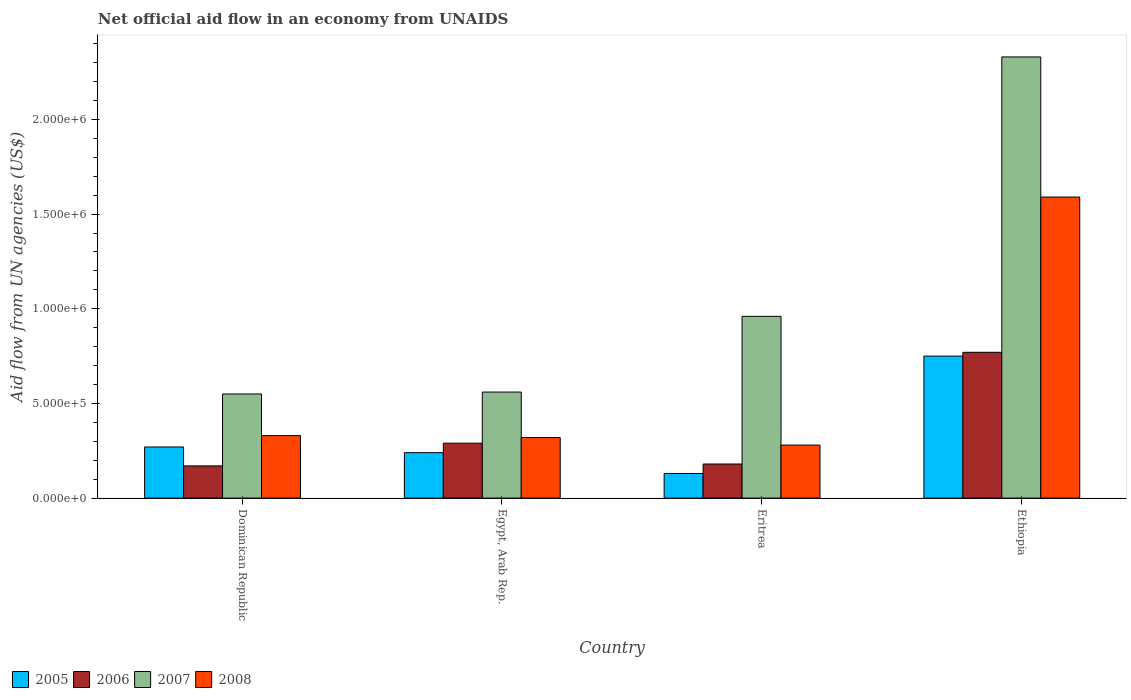How many groups of bars are there?
Offer a terse response. 4. Are the number of bars on each tick of the X-axis equal?
Provide a succinct answer. Yes. How many bars are there on the 3rd tick from the left?
Make the answer very short. 4. How many bars are there on the 2nd tick from the right?
Your answer should be compact. 4. What is the label of the 4th group of bars from the left?
Ensure brevity in your answer.  Ethiopia. Across all countries, what is the maximum net official aid flow in 2007?
Make the answer very short. 2.33e+06. In which country was the net official aid flow in 2007 maximum?
Your answer should be very brief. Ethiopia. In which country was the net official aid flow in 2007 minimum?
Make the answer very short. Dominican Republic. What is the total net official aid flow in 2006 in the graph?
Give a very brief answer. 1.41e+06. What is the difference between the net official aid flow in 2005 in Egypt, Arab Rep. and that in Eritrea?
Keep it short and to the point. 1.10e+05. What is the difference between the net official aid flow in 2007 in Eritrea and the net official aid flow in 2008 in Egypt, Arab Rep.?
Provide a succinct answer. 6.40e+05. What is the average net official aid flow in 2006 per country?
Provide a short and direct response. 3.52e+05. In how many countries, is the net official aid flow in 2008 greater than 1400000 US$?
Your response must be concise. 1. What is the ratio of the net official aid flow in 2005 in Dominican Republic to that in Ethiopia?
Offer a very short reply. 0.36. What is the difference between the highest and the second highest net official aid flow in 2006?
Offer a very short reply. 5.90e+05. What is the difference between the highest and the lowest net official aid flow in 2006?
Provide a short and direct response. 6.00e+05. Is the sum of the net official aid flow in 2005 in Egypt, Arab Rep. and Eritrea greater than the maximum net official aid flow in 2006 across all countries?
Your response must be concise. No. Is it the case that in every country, the sum of the net official aid flow in 2008 and net official aid flow in 2007 is greater than the sum of net official aid flow in 2005 and net official aid flow in 2006?
Keep it short and to the point. Yes. Is it the case that in every country, the sum of the net official aid flow in 2006 and net official aid flow in 2005 is greater than the net official aid flow in 2008?
Your response must be concise. No. Are all the bars in the graph horizontal?
Provide a succinct answer. No. How many countries are there in the graph?
Make the answer very short. 4. What is the difference between two consecutive major ticks on the Y-axis?
Your response must be concise. 5.00e+05. Are the values on the major ticks of Y-axis written in scientific E-notation?
Offer a terse response. Yes. Does the graph contain any zero values?
Provide a succinct answer. No. Does the graph contain grids?
Keep it short and to the point. No. Where does the legend appear in the graph?
Give a very brief answer. Bottom left. How many legend labels are there?
Ensure brevity in your answer.  4. What is the title of the graph?
Give a very brief answer. Net official aid flow in an economy from UNAIDS. Does "2011" appear as one of the legend labels in the graph?
Offer a very short reply. No. What is the label or title of the Y-axis?
Ensure brevity in your answer.  Aid flow from UN agencies (US$). What is the Aid flow from UN agencies (US$) in 2006 in Dominican Republic?
Keep it short and to the point. 1.70e+05. What is the Aid flow from UN agencies (US$) of 2007 in Dominican Republic?
Keep it short and to the point. 5.50e+05. What is the Aid flow from UN agencies (US$) in 2008 in Dominican Republic?
Give a very brief answer. 3.30e+05. What is the Aid flow from UN agencies (US$) of 2007 in Egypt, Arab Rep.?
Offer a very short reply. 5.60e+05. What is the Aid flow from UN agencies (US$) of 2007 in Eritrea?
Your answer should be compact. 9.60e+05. What is the Aid flow from UN agencies (US$) in 2008 in Eritrea?
Your response must be concise. 2.80e+05. What is the Aid flow from UN agencies (US$) of 2005 in Ethiopia?
Your response must be concise. 7.50e+05. What is the Aid flow from UN agencies (US$) in 2006 in Ethiopia?
Offer a terse response. 7.70e+05. What is the Aid flow from UN agencies (US$) in 2007 in Ethiopia?
Your answer should be compact. 2.33e+06. What is the Aid flow from UN agencies (US$) in 2008 in Ethiopia?
Keep it short and to the point. 1.59e+06. Across all countries, what is the maximum Aid flow from UN agencies (US$) in 2005?
Provide a short and direct response. 7.50e+05. Across all countries, what is the maximum Aid flow from UN agencies (US$) of 2006?
Your answer should be very brief. 7.70e+05. Across all countries, what is the maximum Aid flow from UN agencies (US$) in 2007?
Offer a very short reply. 2.33e+06. Across all countries, what is the maximum Aid flow from UN agencies (US$) of 2008?
Provide a short and direct response. 1.59e+06. Across all countries, what is the minimum Aid flow from UN agencies (US$) of 2006?
Make the answer very short. 1.70e+05. Across all countries, what is the minimum Aid flow from UN agencies (US$) in 2008?
Give a very brief answer. 2.80e+05. What is the total Aid flow from UN agencies (US$) in 2005 in the graph?
Your response must be concise. 1.39e+06. What is the total Aid flow from UN agencies (US$) of 2006 in the graph?
Offer a very short reply. 1.41e+06. What is the total Aid flow from UN agencies (US$) of 2007 in the graph?
Your answer should be compact. 4.40e+06. What is the total Aid flow from UN agencies (US$) of 2008 in the graph?
Provide a short and direct response. 2.52e+06. What is the difference between the Aid flow from UN agencies (US$) of 2008 in Dominican Republic and that in Egypt, Arab Rep.?
Make the answer very short. 10000. What is the difference between the Aid flow from UN agencies (US$) in 2005 in Dominican Republic and that in Eritrea?
Offer a terse response. 1.40e+05. What is the difference between the Aid flow from UN agencies (US$) of 2006 in Dominican Republic and that in Eritrea?
Your answer should be compact. -10000. What is the difference between the Aid flow from UN agencies (US$) of 2007 in Dominican Republic and that in Eritrea?
Offer a very short reply. -4.10e+05. What is the difference between the Aid flow from UN agencies (US$) in 2005 in Dominican Republic and that in Ethiopia?
Your answer should be very brief. -4.80e+05. What is the difference between the Aid flow from UN agencies (US$) of 2006 in Dominican Republic and that in Ethiopia?
Your answer should be very brief. -6.00e+05. What is the difference between the Aid flow from UN agencies (US$) of 2007 in Dominican Republic and that in Ethiopia?
Your answer should be compact. -1.78e+06. What is the difference between the Aid flow from UN agencies (US$) in 2008 in Dominican Republic and that in Ethiopia?
Your response must be concise. -1.26e+06. What is the difference between the Aid flow from UN agencies (US$) of 2005 in Egypt, Arab Rep. and that in Eritrea?
Your answer should be compact. 1.10e+05. What is the difference between the Aid flow from UN agencies (US$) of 2007 in Egypt, Arab Rep. and that in Eritrea?
Give a very brief answer. -4.00e+05. What is the difference between the Aid flow from UN agencies (US$) of 2005 in Egypt, Arab Rep. and that in Ethiopia?
Give a very brief answer. -5.10e+05. What is the difference between the Aid flow from UN agencies (US$) of 2006 in Egypt, Arab Rep. and that in Ethiopia?
Give a very brief answer. -4.80e+05. What is the difference between the Aid flow from UN agencies (US$) of 2007 in Egypt, Arab Rep. and that in Ethiopia?
Offer a terse response. -1.77e+06. What is the difference between the Aid flow from UN agencies (US$) in 2008 in Egypt, Arab Rep. and that in Ethiopia?
Provide a succinct answer. -1.27e+06. What is the difference between the Aid flow from UN agencies (US$) in 2005 in Eritrea and that in Ethiopia?
Keep it short and to the point. -6.20e+05. What is the difference between the Aid flow from UN agencies (US$) of 2006 in Eritrea and that in Ethiopia?
Make the answer very short. -5.90e+05. What is the difference between the Aid flow from UN agencies (US$) of 2007 in Eritrea and that in Ethiopia?
Your response must be concise. -1.37e+06. What is the difference between the Aid flow from UN agencies (US$) of 2008 in Eritrea and that in Ethiopia?
Ensure brevity in your answer.  -1.31e+06. What is the difference between the Aid flow from UN agencies (US$) in 2005 in Dominican Republic and the Aid flow from UN agencies (US$) in 2007 in Egypt, Arab Rep.?
Make the answer very short. -2.90e+05. What is the difference between the Aid flow from UN agencies (US$) in 2006 in Dominican Republic and the Aid flow from UN agencies (US$) in 2007 in Egypt, Arab Rep.?
Your answer should be compact. -3.90e+05. What is the difference between the Aid flow from UN agencies (US$) of 2006 in Dominican Republic and the Aid flow from UN agencies (US$) of 2008 in Egypt, Arab Rep.?
Give a very brief answer. -1.50e+05. What is the difference between the Aid flow from UN agencies (US$) of 2005 in Dominican Republic and the Aid flow from UN agencies (US$) of 2007 in Eritrea?
Make the answer very short. -6.90e+05. What is the difference between the Aid flow from UN agencies (US$) in 2006 in Dominican Republic and the Aid flow from UN agencies (US$) in 2007 in Eritrea?
Offer a terse response. -7.90e+05. What is the difference between the Aid flow from UN agencies (US$) in 2007 in Dominican Republic and the Aid flow from UN agencies (US$) in 2008 in Eritrea?
Make the answer very short. 2.70e+05. What is the difference between the Aid flow from UN agencies (US$) of 2005 in Dominican Republic and the Aid flow from UN agencies (US$) of 2006 in Ethiopia?
Provide a short and direct response. -5.00e+05. What is the difference between the Aid flow from UN agencies (US$) of 2005 in Dominican Republic and the Aid flow from UN agencies (US$) of 2007 in Ethiopia?
Your response must be concise. -2.06e+06. What is the difference between the Aid flow from UN agencies (US$) of 2005 in Dominican Republic and the Aid flow from UN agencies (US$) of 2008 in Ethiopia?
Provide a short and direct response. -1.32e+06. What is the difference between the Aid flow from UN agencies (US$) in 2006 in Dominican Republic and the Aid flow from UN agencies (US$) in 2007 in Ethiopia?
Provide a short and direct response. -2.16e+06. What is the difference between the Aid flow from UN agencies (US$) of 2006 in Dominican Republic and the Aid flow from UN agencies (US$) of 2008 in Ethiopia?
Your answer should be very brief. -1.42e+06. What is the difference between the Aid flow from UN agencies (US$) of 2007 in Dominican Republic and the Aid flow from UN agencies (US$) of 2008 in Ethiopia?
Your answer should be very brief. -1.04e+06. What is the difference between the Aid flow from UN agencies (US$) in 2005 in Egypt, Arab Rep. and the Aid flow from UN agencies (US$) in 2007 in Eritrea?
Your response must be concise. -7.20e+05. What is the difference between the Aid flow from UN agencies (US$) in 2005 in Egypt, Arab Rep. and the Aid flow from UN agencies (US$) in 2008 in Eritrea?
Offer a terse response. -4.00e+04. What is the difference between the Aid flow from UN agencies (US$) in 2006 in Egypt, Arab Rep. and the Aid flow from UN agencies (US$) in 2007 in Eritrea?
Your answer should be compact. -6.70e+05. What is the difference between the Aid flow from UN agencies (US$) in 2006 in Egypt, Arab Rep. and the Aid flow from UN agencies (US$) in 2008 in Eritrea?
Give a very brief answer. 10000. What is the difference between the Aid flow from UN agencies (US$) of 2005 in Egypt, Arab Rep. and the Aid flow from UN agencies (US$) of 2006 in Ethiopia?
Make the answer very short. -5.30e+05. What is the difference between the Aid flow from UN agencies (US$) of 2005 in Egypt, Arab Rep. and the Aid flow from UN agencies (US$) of 2007 in Ethiopia?
Your response must be concise. -2.09e+06. What is the difference between the Aid flow from UN agencies (US$) in 2005 in Egypt, Arab Rep. and the Aid flow from UN agencies (US$) in 2008 in Ethiopia?
Offer a very short reply. -1.35e+06. What is the difference between the Aid flow from UN agencies (US$) of 2006 in Egypt, Arab Rep. and the Aid flow from UN agencies (US$) of 2007 in Ethiopia?
Your response must be concise. -2.04e+06. What is the difference between the Aid flow from UN agencies (US$) of 2006 in Egypt, Arab Rep. and the Aid flow from UN agencies (US$) of 2008 in Ethiopia?
Ensure brevity in your answer.  -1.30e+06. What is the difference between the Aid flow from UN agencies (US$) of 2007 in Egypt, Arab Rep. and the Aid flow from UN agencies (US$) of 2008 in Ethiopia?
Provide a succinct answer. -1.03e+06. What is the difference between the Aid flow from UN agencies (US$) of 2005 in Eritrea and the Aid flow from UN agencies (US$) of 2006 in Ethiopia?
Ensure brevity in your answer.  -6.40e+05. What is the difference between the Aid flow from UN agencies (US$) of 2005 in Eritrea and the Aid flow from UN agencies (US$) of 2007 in Ethiopia?
Offer a very short reply. -2.20e+06. What is the difference between the Aid flow from UN agencies (US$) of 2005 in Eritrea and the Aid flow from UN agencies (US$) of 2008 in Ethiopia?
Give a very brief answer. -1.46e+06. What is the difference between the Aid flow from UN agencies (US$) in 2006 in Eritrea and the Aid flow from UN agencies (US$) in 2007 in Ethiopia?
Offer a very short reply. -2.15e+06. What is the difference between the Aid flow from UN agencies (US$) in 2006 in Eritrea and the Aid flow from UN agencies (US$) in 2008 in Ethiopia?
Offer a very short reply. -1.41e+06. What is the difference between the Aid flow from UN agencies (US$) of 2007 in Eritrea and the Aid flow from UN agencies (US$) of 2008 in Ethiopia?
Your answer should be compact. -6.30e+05. What is the average Aid flow from UN agencies (US$) of 2005 per country?
Your response must be concise. 3.48e+05. What is the average Aid flow from UN agencies (US$) of 2006 per country?
Your answer should be very brief. 3.52e+05. What is the average Aid flow from UN agencies (US$) in 2007 per country?
Your answer should be compact. 1.10e+06. What is the average Aid flow from UN agencies (US$) in 2008 per country?
Provide a short and direct response. 6.30e+05. What is the difference between the Aid flow from UN agencies (US$) of 2005 and Aid flow from UN agencies (US$) of 2007 in Dominican Republic?
Your response must be concise. -2.80e+05. What is the difference between the Aid flow from UN agencies (US$) of 2005 and Aid flow from UN agencies (US$) of 2008 in Dominican Republic?
Your response must be concise. -6.00e+04. What is the difference between the Aid flow from UN agencies (US$) of 2006 and Aid flow from UN agencies (US$) of 2007 in Dominican Republic?
Offer a terse response. -3.80e+05. What is the difference between the Aid flow from UN agencies (US$) of 2006 and Aid flow from UN agencies (US$) of 2008 in Dominican Republic?
Provide a short and direct response. -1.60e+05. What is the difference between the Aid flow from UN agencies (US$) of 2007 and Aid flow from UN agencies (US$) of 2008 in Dominican Republic?
Your response must be concise. 2.20e+05. What is the difference between the Aid flow from UN agencies (US$) of 2005 and Aid flow from UN agencies (US$) of 2006 in Egypt, Arab Rep.?
Offer a very short reply. -5.00e+04. What is the difference between the Aid flow from UN agencies (US$) in 2005 and Aid flow from UN agencies (US$) in 2007 in Egypt, Arab Rep.?
Provide a succinct answer. -3.20e+05. What is the difference between the Aid flow from UN agencies (US$) of 2006 and Aid flow from UN agencies (US$) of 2007 in Egypt, Arab Rep.?
Give a very brief answer. -2.70e+05. What is the difference between the Aid flow from UN agencies (US$) in 2006 and Aid flow from UN agencies (US$) in 2008 in Egypt, Arab Rep.?
Keep it short and to the point. -3.00e+04. What is the difference between the Aid flow from UN agencies (US$) of 2007 and Aid flow from UN agencies (US$) of 2008 in Egypt, Arab Rep.?
Provide a succinct answer. 2.40e+05. What is the difference between the Aid flow from UN agencies (US$) in 2005 and Aid flow from UN agencies (US$) in 2006 in Eritrea?
Your answer should be compact. -5.00e+04. What is the difference between the Aid flow from UN agencies (US$) of 2005 and Aid flow from UN agencies (US$) of 2007 in Eritrea?
Offer a very short reply. -8.30e+05. What is the difference between the Aid flow from UN agencies (US$) of 2006 and Aid flow from UN agencies (US$) of 2007 in Eritrea?
Your answer should be compact. -7.80e+05. What is the difference between the Aid flow from UN agencies (US$) in 2007 and Aid flow from UN agencies (US$) in 2008 in Eritrea?
Give a very brief answer. 6.80e+05. What is the difference between the Aid flow from UN agencies (US$) in 2005 and Aid flow from UN agencies (US$) in 2006 in Ethiopia?
Make the answer very short. -2.00e+04. What is the difference between the Aid flow from UN agencies (US$) of 2005 and Aid flow from UN agencies (US$) of 2007 in Ethiopia?
Keep it short and to the point. -1.58e+06. What is the difference between the Aid flow from UN agencies (US$) in 2005 and Aid flow from UN agencies (US$) in 2008 in Ethiopia?
Your answer should be compact. -8.40e+05. What is the difference between the Aid flow from UN agencies (US$) of 2006 and Aid flow from UN agencies (US$) of 2007 in Ethiopia?
Your response must be concise. -1.56e+06. What is the difference between the Aid flow from UN agencies (US$) in 2006 and Aid flow from UN agencies (US$) in 2008 in Ethiopia?
Give a very brief answer. -8.20e+05. What is the difference between the Aid flow from UN agencies (US$) of 2007 and Aid flow from UN agencies (US$) of 2008 in Ethiopia?
Provide a short and direct response. 7.40e+05. What is the ratio of the Aid flow from UN agencies (US$) of 2005 in Dominican Republic to that in Egypt, Arab Rep.?
Your answer should be compact. 1.12. What is the ratio of the Aid flow from UN agencies (US$) in 2006 in Dominican Republic to that in Egypt, Arab Rep.?
Your answer should be very brief. 0.59. What is the ratio of the Aid flow from UN agencies (US$) of 2007 in Dominican Republic to that in Egypt, Arab Rep.?
Your answer should be very brief. 0.98. What is the ratio of the Aid flow from UN agencies (US$) in 2008 in Dominican Republic to that in Egypt, Arab Rep.?
Provide a succinct answer. 1.03. What is the ratio of the Aid flow from UN agencies (US$) in 2005 in Dominican Republic to that in Eritrea?
Give a very brief answer. 2.08. What is the ratio of the Aid flow from UN agencies (US$) in 2007 in Dominican Republic to that in Eritrea?
Your answer should be very brief. 0.57. What is the ratio of the Aid flow from UN agencies (US$) in 2008 in Dominican Republic to that in Eritrea?
Your answer should be very brief. 1.18. What is the ratio of the Aid flow from UN agencies (US$) of 2005 in Dominican Republic to that in Ethiopia?
Your response must be concise. 0.36. What is the ratio of the Aid flow from UN agencies (US$) of 2006 in Dominican Republic to that in Ethiopia?
Ensure brevity in your answer.  0.22. What is the ratio of the Aid flow from UN agencies (US$) in 2007 in Dominican Republic to that in Ethiopia?
Offer a terse response. 0.24. What is the ratio of the Aid flow from UN agencies (US$) of 2008 in Dominican Republic to that in Ethiopia?
Your answer should be very brief. 0.21. What is the ratio of the Aid flow from UN agencies (US$) of 2005 in Egypt, Arab Rep. to that in Eritrea?
Provide a succinct answer. 1.85. What is the ratio of the Aid flow from UN agencies (US$) in 2006 in Egypt, Arab Rep. to that in Eritrea?
Offer a terse response. 1.61. What is the ratio of the Aid flow from UN agencies (US$) in 2007 in Egypt, Arab Rep. to that in Eritrea?
Provide a succinct answer. 0.58. What is the ratio of the Aid flow from UN agencies (US$) in 2005 in Egypt, Arab Rep. to that in Ethiopia?
Your answer should be compact. 0.32. What is the ratio of the Aid flow from UN agencies (US$) in 2006 in Egypt, Arab Rep. to that in Ethiopia?
Keep it short and to the point. 0.38. What is the ratio of the Aid flow from UN agencies (US$) of 2007 in Egypt, Arab Rep. to that in Ethiopia?
Your answer should be compact. 0.24. What is the ratio of the Aid flow from UN agencies (US$) in 2008 in Egypt, Arab Rep. to that in Ethiopia?
Provide a short and direct response. 0.2. What is the ratio of the Aid flow from UN agencies (US$) of 2005 in Eritrea to that in Ethiopia?
Make the answer very short. 0.17. What is the ratio of the Aid flow from UN agencies (US$) in 2006 in Eritrea to that in Ethiopia?
Give a very brief answer. 0.23. What is the ratio of the Aid flow from UN agencies (US$) of 2007 in Eritrea to that in Ethiopia?
Ensure brevity in your answer.  0.41. What is the ratio of the Aid flow from UN agencies (US$) in 2008 in Eritrea to that in Ethiopia?
Your answer should be very brief. 0.18. What is the difference between the highest and the second highest Aid flow from UN agencies (US$) of 2006?
Give a very brief answer. 4.80e+05. What is the difference between the highest and the second highest Aid flow from UN agencies (US$) of 2007?
Ensure brevity in your answer.  1.37e+06. What is the difference between the highest and the second highest Aid flow from UN agencies (US$) in 2008?
Provide a short and direct response. 1.26e+06. What is the difference between the highest and the lowest Aid flow from UN agencies (US$) in 2005?
Your answer should be compact. 6.20e+05. What is the difference between the highest and the lowest Aid flow from UN agencies (US$) in 2006?
Provide a short and direct response. 6.00e+05. What is the difference between the highest and the lowest Aid flow from UN agencies (US$) in 2007?
Make the answer very short. 1.78e+06. What is the difference between the highest and the lowest Aid flow from UN agencies (US$) in 2008?
Provide a short and direct response. 1.31e+06. 